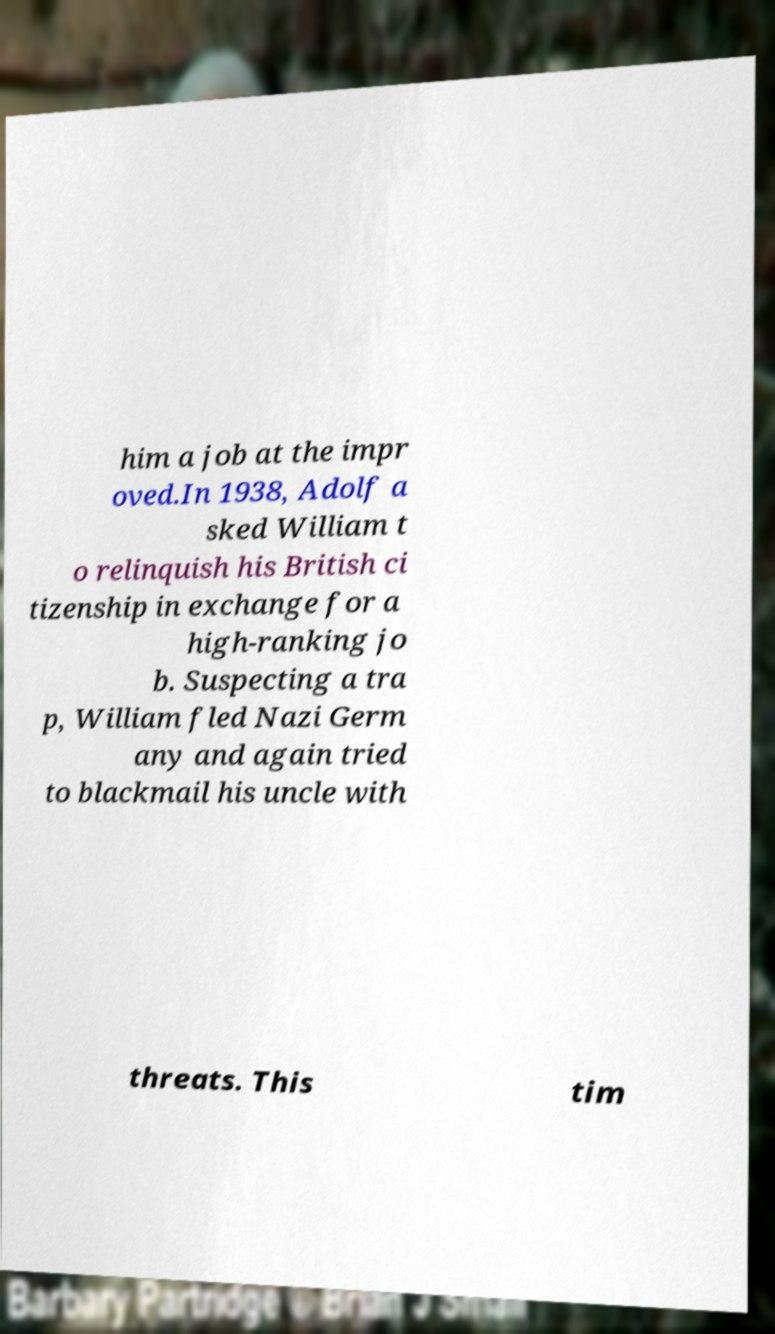Please identify and transcribe the text found in this image. him a job at the impr oved.In 1938, Adolf a sked William t o relinquish his British ci tizenship in exchange for a high-ranking jo b. Suspecting a tra p, William fled Nazi Germ any and again tried to blackmail his uncle with threats. This tim 